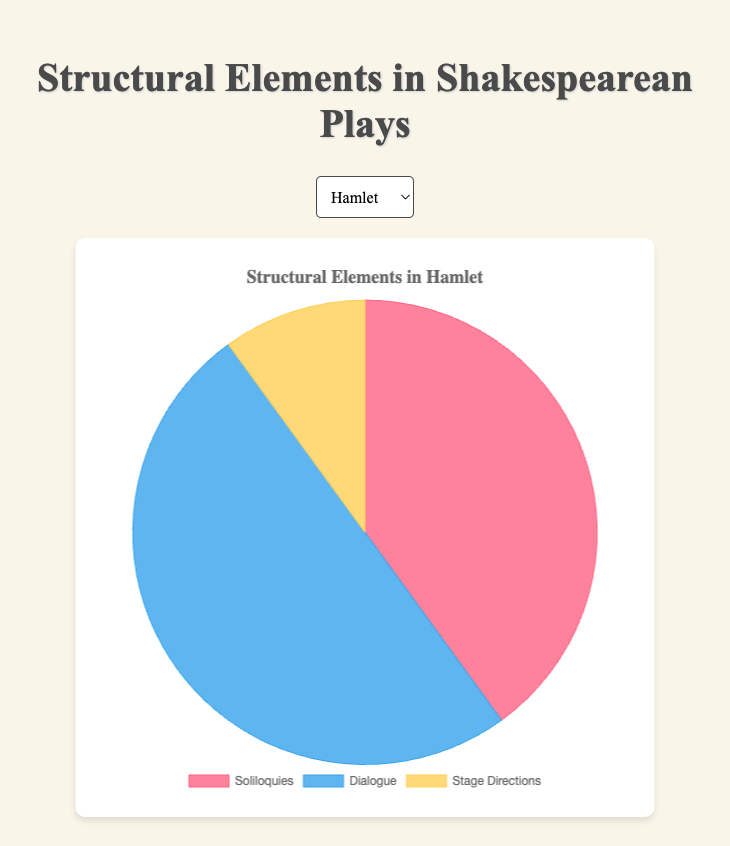what percentage of Hamlet's structural elements are Dialogue? First, identify the amount of Dialogue in Hamlet, which is 50. Next, find the total sum of all elements in Hamlet: 40 (Soliloquies) + 50 (Dialogue) + 10 (Stage Directions) = 100. Finally, calculate the percentage: (50 / 100) * 100 = 50%
Answer: 50% Which play has the highest percentage of Stage Directions? Compare the percentage of Stage Directions in each play: Hamlet (10%), Macbeth (10%), and Othello (15%). Othello has the highest percentage.
Answer: Othello What is the total number of Dialogue elements across all three plays? Sum the number of Dialogue elements for each play: Hamlet (50) + Macbeth (55) + Othello (55) = 160.
Answer: 160 Compare the number of Soliloquies in Hamlet to Macbeth. Which play has more and by how many? Hamlet has 40 Soliloquies and Macbeth has 35. Subtract 35 from 40: 40 - 35 = 5. Hamlet has 5 more Soliloquies.
Answer: Hamlet, by 5 What is the average number of Stage Directions in these plays? Sum the number of Stage Directions for each play: Hamlet (10) + Macbeth (10) + Othello (15) = 35. Divide by the number of plays (3): 35 / 3 ≈ 11.67.
Answer: ≈ 11.67 How does the percentage of Soliloquies in Macbeth compare to Othello? First, find the percentage of Soliloquies in each play:
Macbeth: (35 / (35 + 55 + 10)) * 100 = (35 / 100) * 100 = 35%
Othello: (30 / (30 + 55 + 15)) * 100 = (30 / 100) * 100 = 30%
Macbeth has a higher percentage of Soliloquies than Othello, with a difference of 5%.
Answer: Macbeth by 5% Which is the smallest segment among the given structural elements in Hamlet, and what is its percentage? Identify the smallest segment, which is Stage Directions (10). Find its percentage: (10 / 100) * 100 = 10%.
Answer: Stage Directions, 10% What can be observed about the proportion of Dialogue in Othello? Dialogue forms the largest proportion in Othello, accounting for 55% of the structural elements.
Answer: Dialogue, 55% What is the difference in the total number of Soliloquies between Hamlet and Othello? Determine the number of Soliloquies in Hamlet (40) and Othello (30). Calculate the difference: 40 - 30 = 10.
Answer: 10 Which structural element is represented by the color red in the Pie chart? According to the provided information, Soliloquies are represented by the color red.
Answer: Soliloquies 